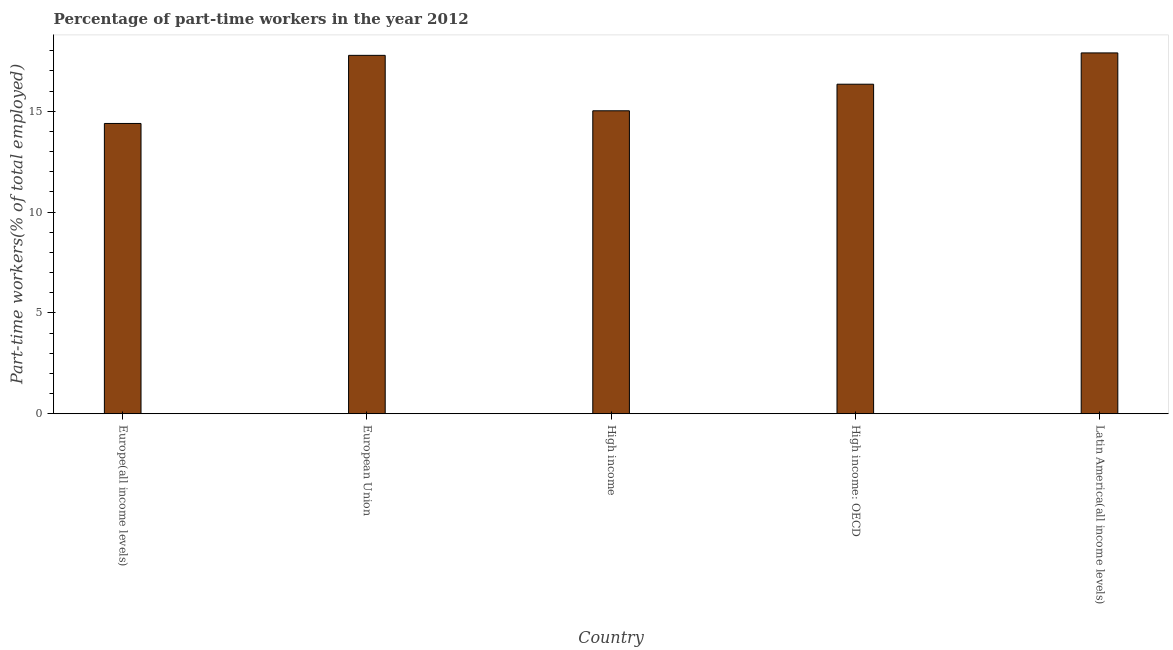Does the graph contain grids?
Offer a terse response. No. What is the title of the graph?
Your answer should be very brief. Percentage of part-time workers in the year 2012. What is the label or title of the X-axis?
Your response must be concise. Country. What is the label or title of the Y-axis?
Provide a succinct answer. Part-time workers(% of total employed). What is the percentage of part-time workers in High income?
Your response must be concise. 15.02. Across all countries, what is the maximum percentage of part-time workers?
Offer a very short reply. 17.89. Across all countries, what is the minimum percentage of part-time workers?
Keep it short and to the point. 14.39. In which country was the percentage of part-time workers maximum?
Offer a terse response. Latin America(all income levels). In which country was the percentage of part-time workers minimum?
Offer a terse response. Europe(all income levels). What is the sum of the percentage of part-time workers?
Make the answer very short. 81.41. What is the difference between the percentage of part-time workers in European Union and High income?
Provide a short and direct response. 2.75. What is the average percentage of part-time workers per country?
Your answer should be very brief. 16.28. What is the median percentage of part-time workers?
Provide a short and direct response. 16.34. What is the ratio of the percentage of part-time workers in Europe(all income levels) to that in High income: OECD?
Ensure brevity in your answer.  0.88. What is the difference between the highest and the second highest percentage of part-time workers?
Give a very brief answer. 0.12. What is the difference between the highest and the lowest percentage of part-time workers?
Offer a very short reply. 3.5. In how many countries, is the percentage of part-time workers greater than the average percentage of part-time workers taken over all countries?
Provide a short and direct response. 3. How many bars are there?
Your response must be concise. 5. What is the difference between two consecutive major ticks on the Y-axis?
Your response must be concise. 5. Are the values on the major ticks of Y-axis written in scientific E-notation?
Your response must be concise. No. What is the Part-time workers(% of total employed) of Europe(all income levels)?
Offer a terse response. 14.39. What is the Part-time workers(% of total employed) in European Union?
Your answer should be compact. 17.77. What is the Part-time workers(% of total employed) in High income?
Make the answer very short. 15.02. What is the Part-time workers(% of total employed) in High income: OECD?
Your response must be concise. 16.34. What is the Part-time workers(% of total employed) of Latin America(all income levels)?
Make the answer very short. 17.89. What is the difference between the Part-time workers(% of total employed) in Europe(all income levels) and European Union?
Your answer should be compact. -3.38. What is the difference between the Part-time workers(% of total employed) in Europe(all income levels) and High income?
Offer a terse response. -0.63. What is the difference between the Part-time workers(% of total employed) in Europe(all income levels) and High income: OECD?
Give a very brief answer. -1.95. What is the difference between the Part-time workers(% of total employed) in Europe(all income levels) and Latin America(all income levels)?
Offer a terse response. -3.5. What is the difference between the Part-time workers(% of total employed) in European Union and High income?
Provide a short and direct response. 2.75. What is the difference between the Part-time workers(% of total employed) in European Union and High income: OECD?
Offer a very short reply. 1.43. What is the difference between the Part-time workers(% of total employed) in European Union and Latin America(all income levels)?
Provide a short and direct response. -0.12. What is the difference between the Part-time workers(% of total employed) in High income and High income: OECD?
Give a very brief answer. -1.32. What is the difference between the Part-time workers(% of total employed) in High income and Latin America(all income levels)?
Provide a short and direct response. -2.87. What is the difference between the Part-time workers(% of total employed) in High income: OECD and Latin America(all income levels)?
Make the answer very short. -1.55. What is the ratio of the Part-time workers(% of total employed) in Europe(all income levels) to that in European Union?
Give a very brief answer. 0.81. What is the ratio of the Part-time workers(% of total employed) in Europe(all income levels) to that in High income?
Offer a very short reply. 0.96. What is the ratio of the Part-time workers(% of total employed) in Europe(all income levels) to that in High income: OECD?
Keep it short and to the point. 0.88. What is the ratio of the Part-time workers(% of total employed) in Europe(all income levels) to that in Latin America(all income levels)?
Make the answer very short. 0.8. What is the ratio of the Part-time workers(% of total employed) in European Union to that in High income?
Ensure brevity in your answer.  1.18. What is the ratio of the Part-time workers(% of total employed) in European Union to that in High income: OECD?
Your answer should be compact. 1.09. What is the ratio of the Part-time workers(% of total employed) in European Union to that in Latin America(all income levels)?
Provide a succinct answer. 0.99. What is the ratio of the Part-time workers(% of total employed) in High income to that in High income: OECD?
Your answer should be compact. 0.92. What is the ratio of the Part-time workers(% of total employed) in High income to that in Latin America(all income levels)?
Your answer should be compact. 0.84. 